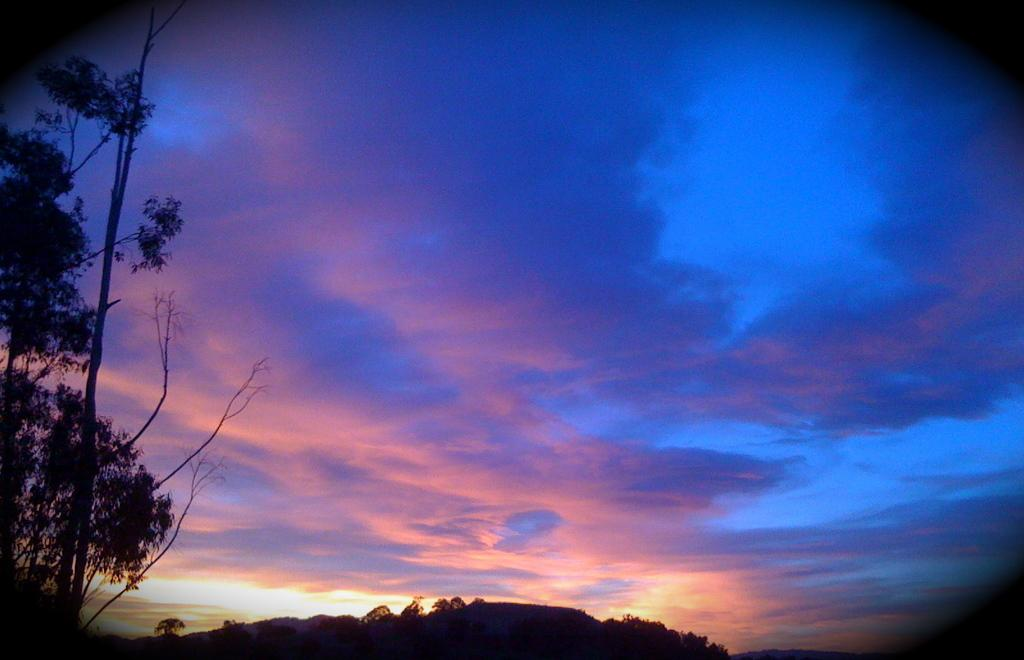What type of vegetation can be seen in the image? There are trees in the image. What is visible in the background of the image? The sky is visible in the background of the image. What can be observed in the sky? Clouds are present in the sky. What is the purpose of the silver station in the image? There is no silver station present in the image. 